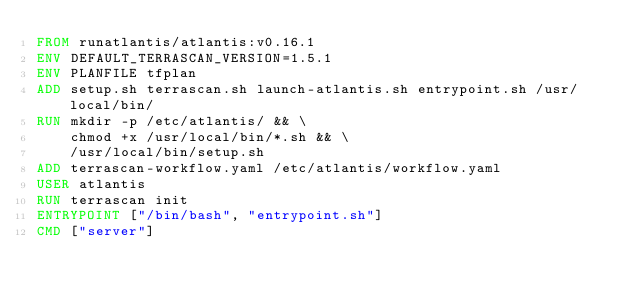<code> <loc_0><loc_0><loc_500><loc_500><_Dockerfile_>FROM runatlantis/atlantis:v0.16.1
ENV DEFAULT_TERRASCAN_VERSION=1.5.1
ENV PLANFILE tfplan
ADD setup.sh terrascan.sh launch-atlantis.sh entrypoint.sh /usr/local/bin/
RUN mkdir -p /etc/atlantis/ && \
    chmod +x /usr/local/bin/*.sh && \
    /usr/local/bin/setup.sh
ADD terrascan-workflow.yaml /etc/atlantis/workflow.yaml
USER atlantis
RUN terrascan init
ENTRYPOINT ["/bin/bash", "entrypoint.sh"]
CMD ["server"]
</code> 